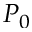<formula> <loc_0><loc_0><loc_500><loc_500>P _ { 0 }</formula> 